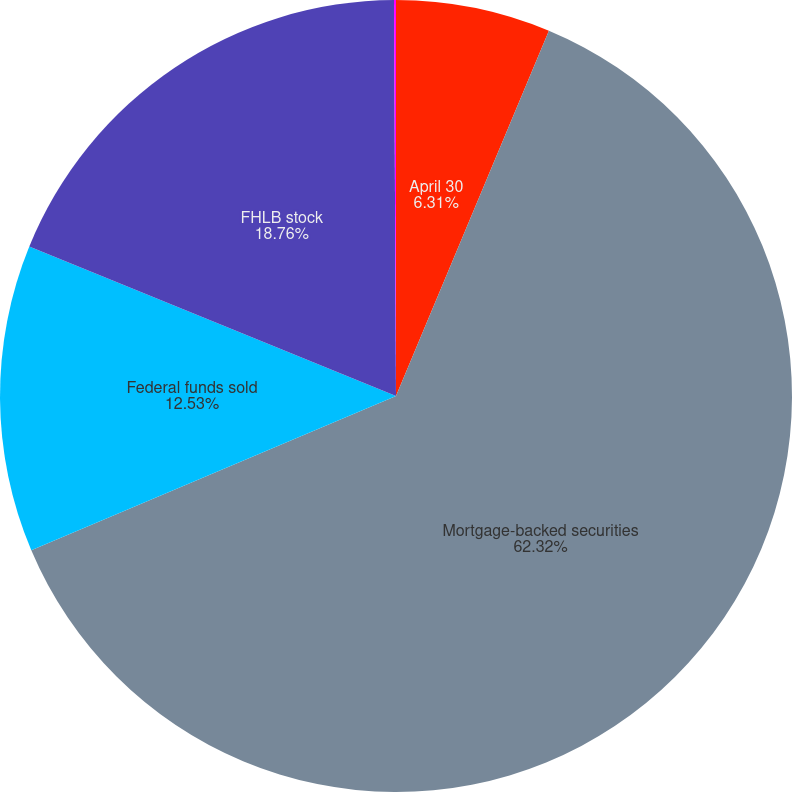<chart> <loc_0><loc_0><loc_500><loc_500><pie_chart><fcel>April 30<fcel>Mortgage-backed securities<fcel>Federal funds sold<fcel>FHLB stock<fcel>Trust preferred security<nl><fcel>6.31%<fcel>62.32%<fcel>12.53%<fcel>18.76%<fcel>0.08%<nl></chart> 